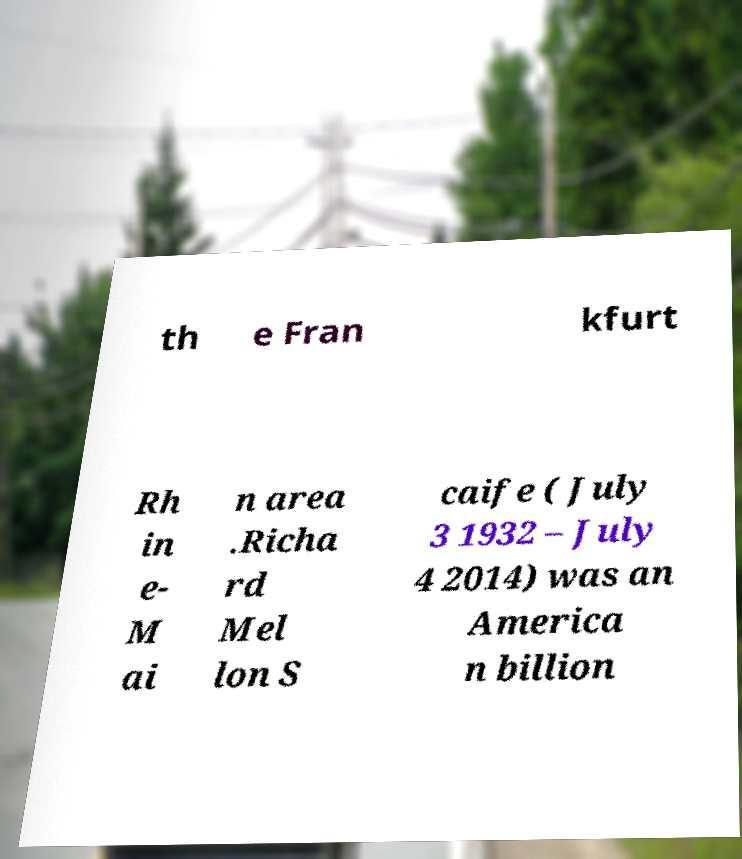Could you extract and type out the text from this image? th e Fran kfurt Rh in e- M ai n area .Richa rd Mel lon S caife ( July 3 1932 – July 4 2014) was an America n billion 